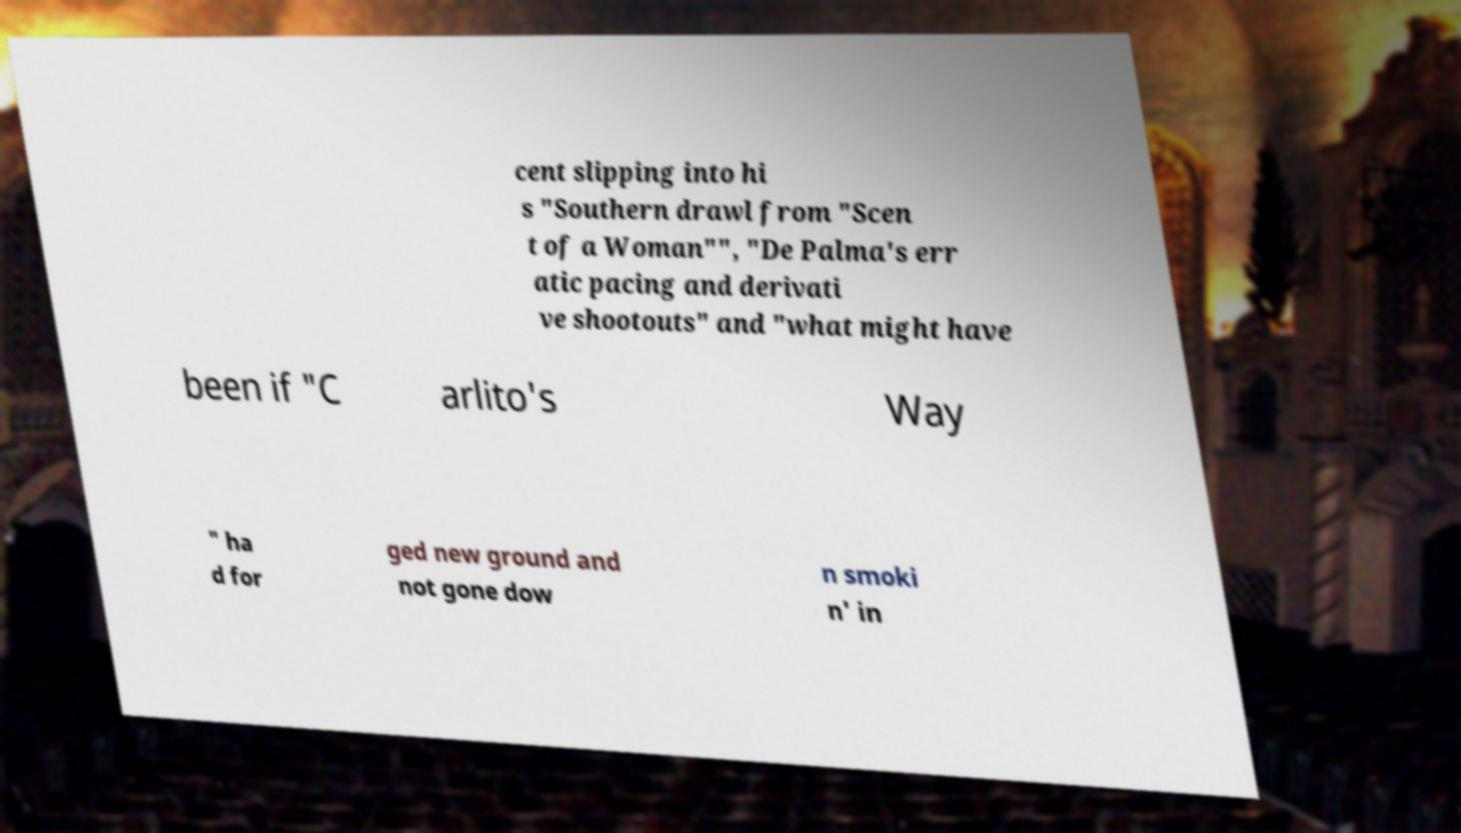Please identify and transcribe the text found in this image. cent slipping into hi s "Southern drawl from "Scen t of a Woman"", "De Palma's err atic pacing and derivati ve shootouts" and "what might have been if "C arlito's Way " ha d for ged new ground and not gone dow n smoki n' in 